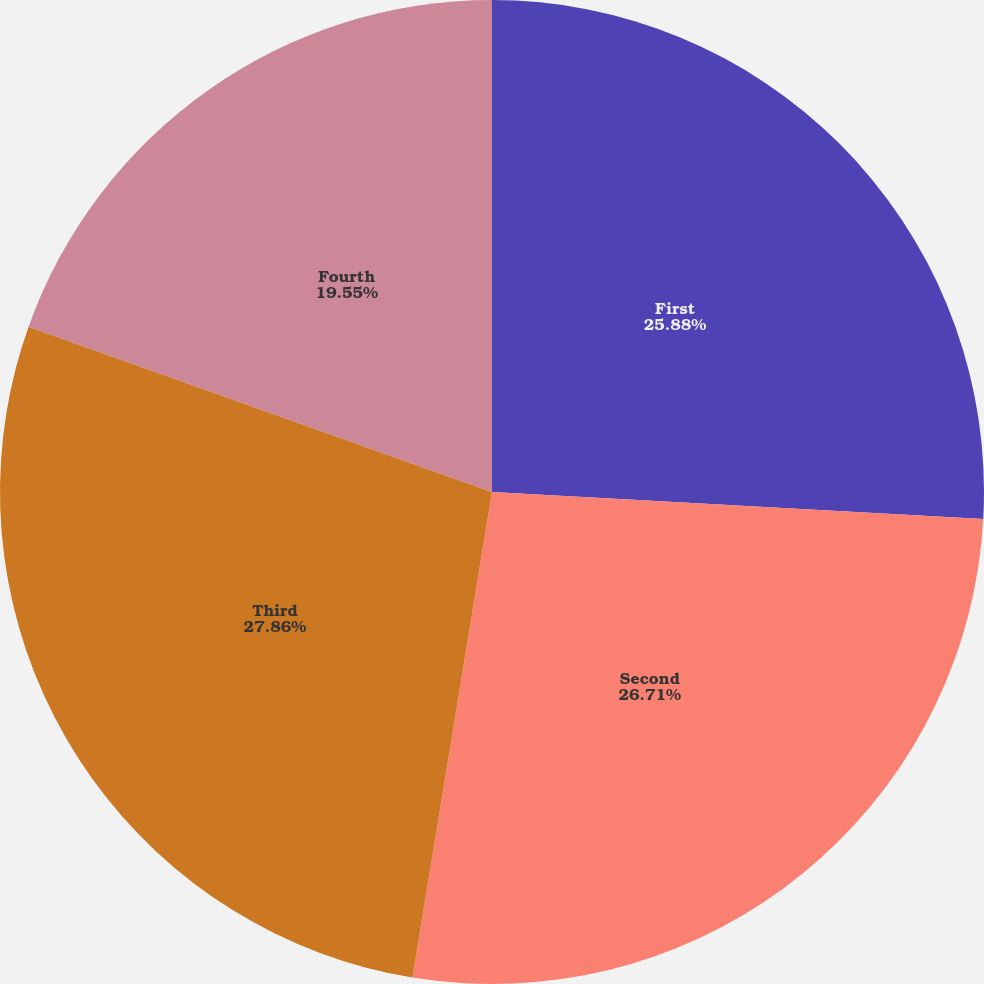<chart> <loc_0><loc_0><loc_500><loc_500><pie_chart><fcel>First<fcel>Second<fcel>Third<fcel>Fourth<nl><fcel>25.88%<fcel>26.71%<fcel>27.87%<fcel>19.55%<nl></chart> 